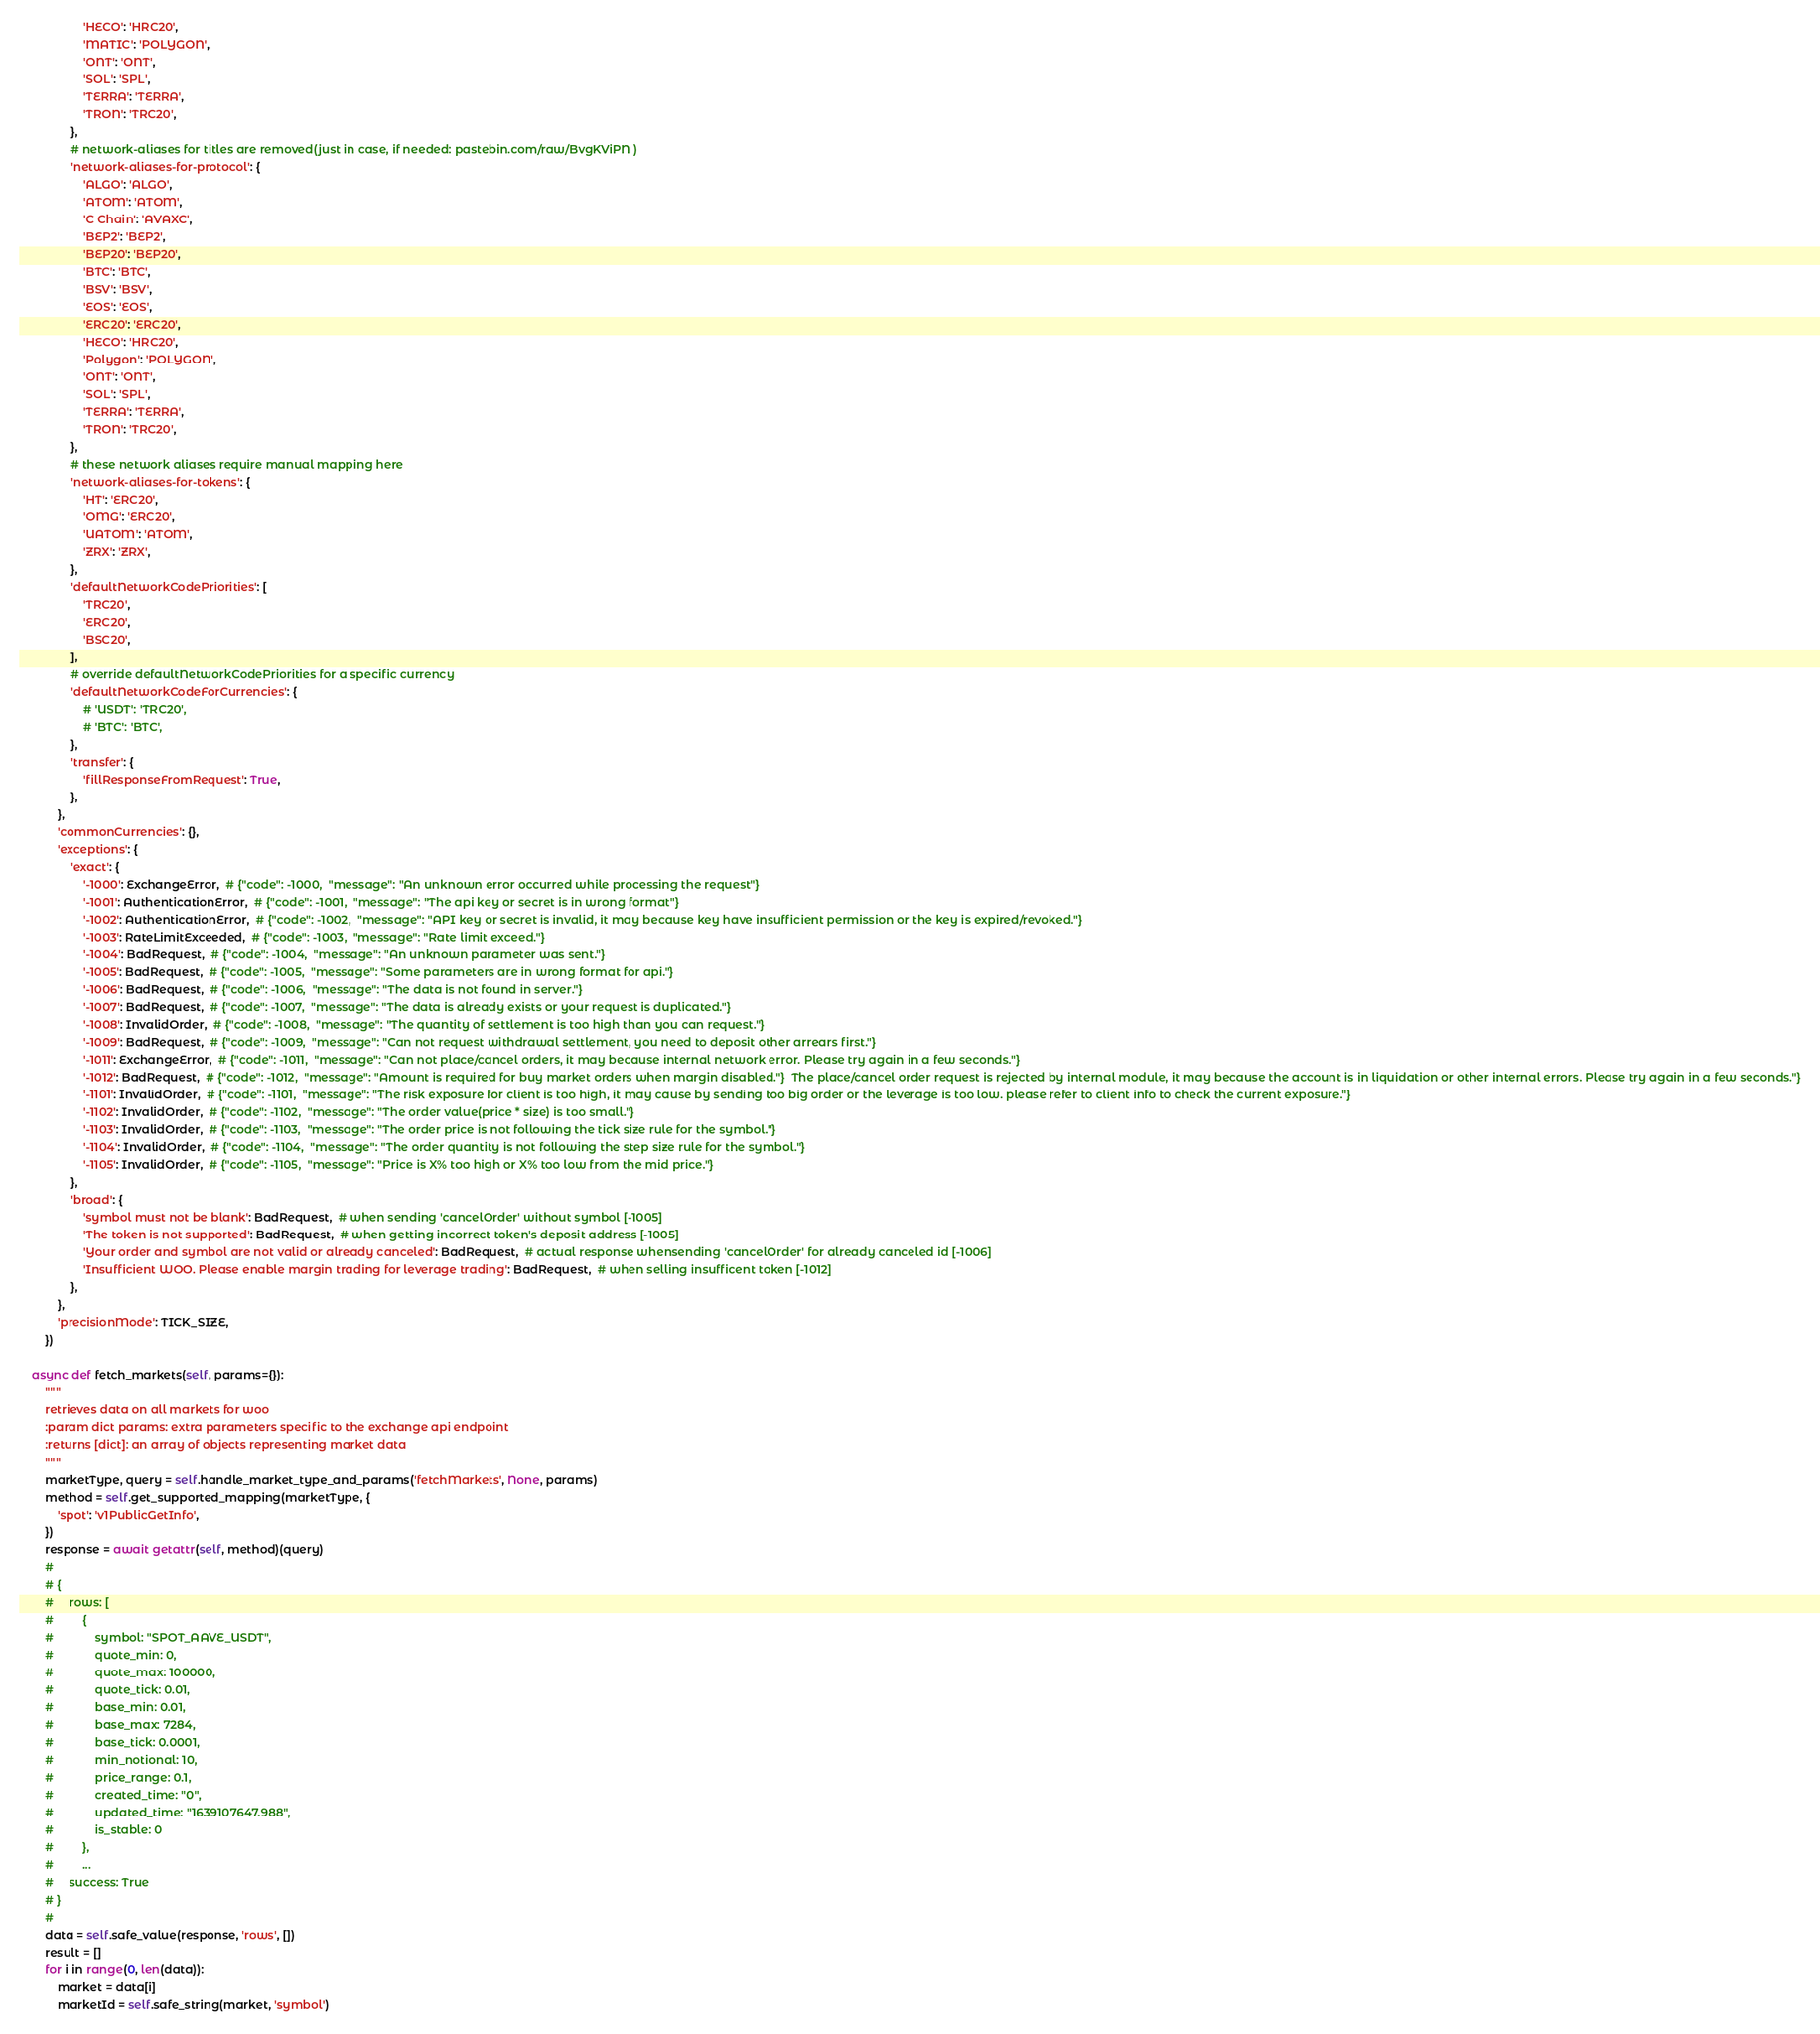<code> <loc_0><loc_0><loc_500><loc_500><_Python_>                    'HECO': 'HRC20',
                    'MATIC': 'POLYGON',
                    'ONT': 'ONT',
                    'SOL': 'SPL',
                    'TERRA': 'TERRA',
                    'TRON': 'TRC20',
                },
                # network-aliases for titles are removed(just in case, if needed: pastebin.com/raw/BvgKViPN )
                'network-aliases-for-protocol': {
                    'ALGO': 'ALGO',
                    'ATOM': 'ATOM',
                    'C Chain': 'AVAXC',
                    'BEP2': 'BEP2',
                    'BEP20': 'BEP20',
                    'BTC': 'BTC',
                    'BSV': 'BSV',
                    'EOS': 'EOS',
                    'ERC20': 'ERC20',
                    'HECO': 'HRC20',
                    'Polygon': 'POLYGON',
                    'ONT': 'ONT',
                    'SOL': 'SPL',
                    'TERRA': 'TERRA',
                    'TRON': 'TRC20',
                },
                # these network aliases require manual mapping here
                'network-aliases-for-tokens': {
                    'HT': 'ERC20',
                    'OMG': 'ERC20',
                    'UATOM': 'ATOM',
                    'ZRX': 'ZRX',
                },
                'defaultNetworkCodePriorities': [
                    'TRC20',
                    'ERC20',
                    'BSC20',
                ],
                # override defaultNetworkCodePriorities for a specific currency
                'defaultNetworkCodeForCurrencies': {
                    # 'USDT': 'TRC20',
                    # 'BTC': 'BTC',
                },
                'transfer': {
                    'fillResponseFromRequest': True,
                },
            },
            'commonCurrencies': {},
            'exceptions': {
                'exact': {
                    '-1000': ExchangeError,  # {"code": -1000,  "message": "An unknown error occurred while processing the request"}
                    '-1001': AuthenticationError,  # {"code": -1001,  "message": "The api key or secret is in wrong format"}
                    '-1002': AuthenticationError,  # {"code": -1002,  "message": "API key or secret is invalid, it may because key have insufficient permission or the key is expired/revoked."}
                    '-1003': RateLimitExceeded,  # {"code": -1003,  "message": "Rate limit exceed."}
                    '-1004': BadRequest,  # {"code": -1004,  "message": "An unknown parameter was sent."}
                    '-1005': BadRequest,  # {"code": -1005,  "message": "Some parameters are in wrong format for api."}
                    '-1006': BadRequest,  # {"code": -1006,  "message": "The data is not found in server."}
                    '-1007': BadRequest,  # {"code": -1007,  "message": "The data is already exists or your request is duplicated."}
                    '-1008': InvalidOrder,  # {"code": -1008,  "message": "The quantity of settlement is too high than you can request."}
                    '-1009': BadRequest,  # {"code": -1009,  "message": "Can not request withdrawal settlement, you need to deposit other arrears first."}
                    '-1011': ExchangeError,  # {"code": -1011,  "message": "Can not place/cancel orders, it may because internal network error. Please try again in a few seconds."}
                    '-1012': BadRequest,  # {"code": -1012,  "message": "Amount is required for buy market orders when margin disabled."}  The place/cancel order request is rejected by internal module, it may because the account is in liquidation or other internal errors. Please try again in a few seconds."}
                    '-1101': InvalidOrder,  # {"code": -1101,  "message": "The risk exposure for client is too high, it may cause by sending too big order or the leverage is too low. please refer to client info to check the current exposure."}
                    '-1102': InvalidOrder,  # {"code": -1102,  "message": "The order value(price * size) is too small."}
                    '-1103': InvalidOrder,  # {"code": -1103,  "message": "The order price is not following the tick size rule for the symbol."}
                    '-1104': InvalidOrder,  # {"code": -1104,  "message": "The order quantity is not following the step size rule for the symbol."}
                    '-1105': InvalidOrder,  # {"code": -1105,  "message": "Price is X% too high or X% too low from the mid price."}
                },
                'broad': {
                    'symbol must not be blank': BadRequest,  # when sending 'cancelOrder' without symbol [-1005]
                    'The token is not supported': BadRequest,  # when getting incorrect token's deposit address [-1005]
                    'Your order and symbol are not valid or already canceled': BadRequest,  # actual response whensending 'cancelOrder' for already canceled id [-1006]
                    'Insufficient WOO. Please enable margin trading for leverage trading': BadRequest,  # when selling insufficent token [-1012]
                },
            },
            'precisionMode': TICK_SIZE,
        })

    async def fetch_markets(self, params={}):
        """
        retrieves data on all markets for woo
        :param dict params: extra parameters specific to the exchange api endpoint
        :returns [dict]: an array of objects representing market data
        """
        marketType, query = self.handle_market_type_and_params('fetchMarkets', None, params)
        method = self.get_supported_mapping(marketType, {
            'spot': 'v1PublicGetInfo',
        })
        response = await getattr(self, method)(query)
        #
        # {
        #     rows: [
        #         {
        #             symbol: "SPOT_AAVE_USDT",
        #             quote_min: 0,
        #             quote_max: 100000,
        #             quote_tick: 0.01,
        #             base_min: 0.01,
        #             base_max: 7284,
        #             base_tick: 0.0001,
        #             min_notional: 10,
        #             price_range: 0.1,
        #             created_time: "0",
        #             updated_time: "1639107647.988",
        #             is_stable: 0
        #         },
        #         ...
        #     success: True
        # }
        #
        data = self.safe_value(response, 'rows', [])
        result = []
        for i in range(0, len(data)):
            market = data[i]
            marketId = self.safe_string(market, 'symbol')</code> 